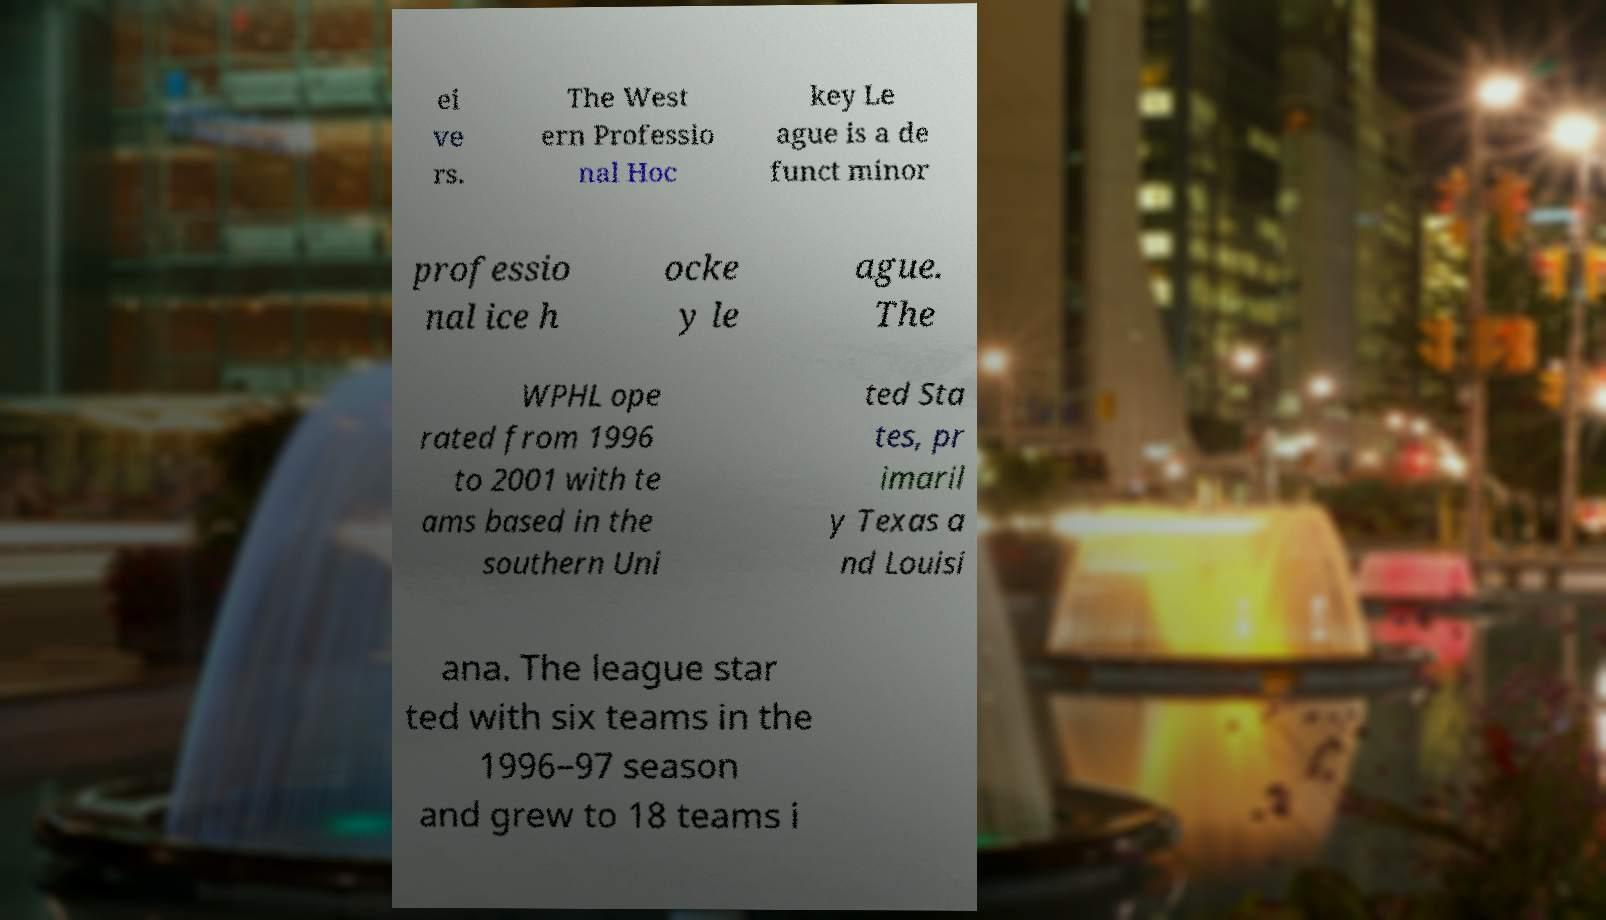Can you accurately transcribe the text from the provided image for me? ei ve rs. The West ern Professio nal Hoc key Le ague is a de funct minor professio nal ice h ocke y le ague. The WPHL ope rated from 1996 to 2001 with te ams based in the southern Uni ted Sta tes, pr imaril y Texas a nd Louisi ana. The league star ted with six teams in the 1996–97 season and grew to 18 teams i 